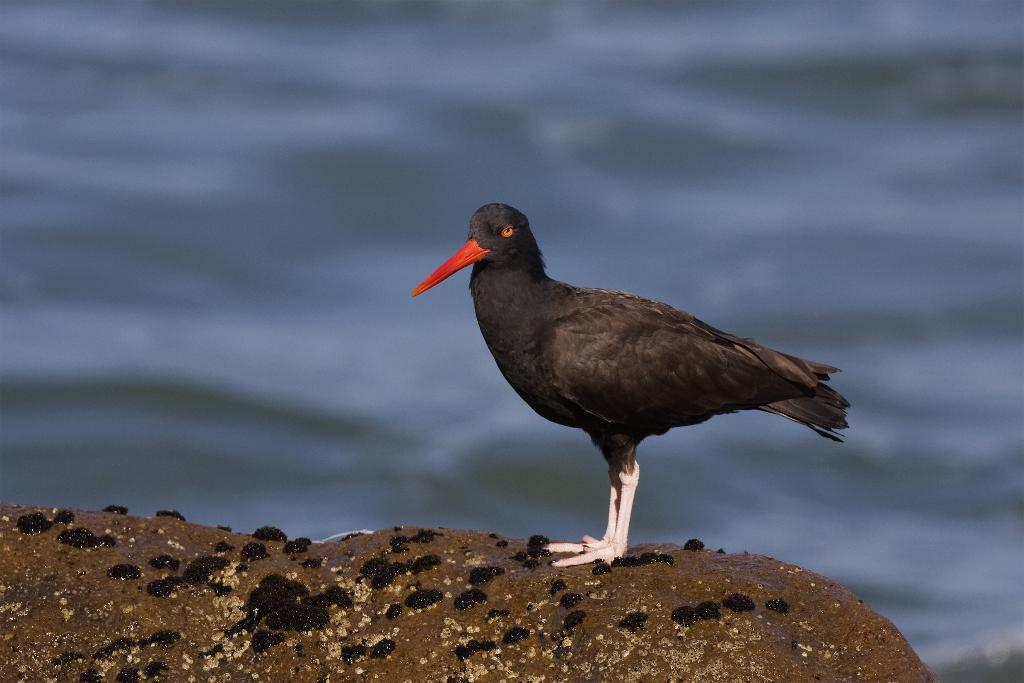What type of animal is in the image? There is a bird in the image. What is the bird standing on? The bird is standing on an object that appears to be a rock. Can you describe the background of the image? The background of the image is blurry. What type of wax is visible on the bird's feathers in the image? There is no wax visible on the bird's feathers in the image. How does the coastline appear in the image? There is no coastline present in the image; it features a bird standing on a rock with a blurry background. 